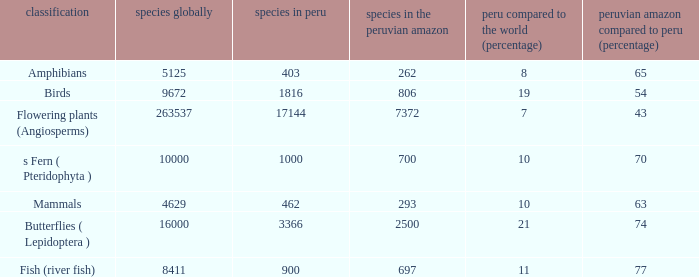What's the minimum species in the peruvian amazon with peru vs. world (percent) value of 7 7372.0. 